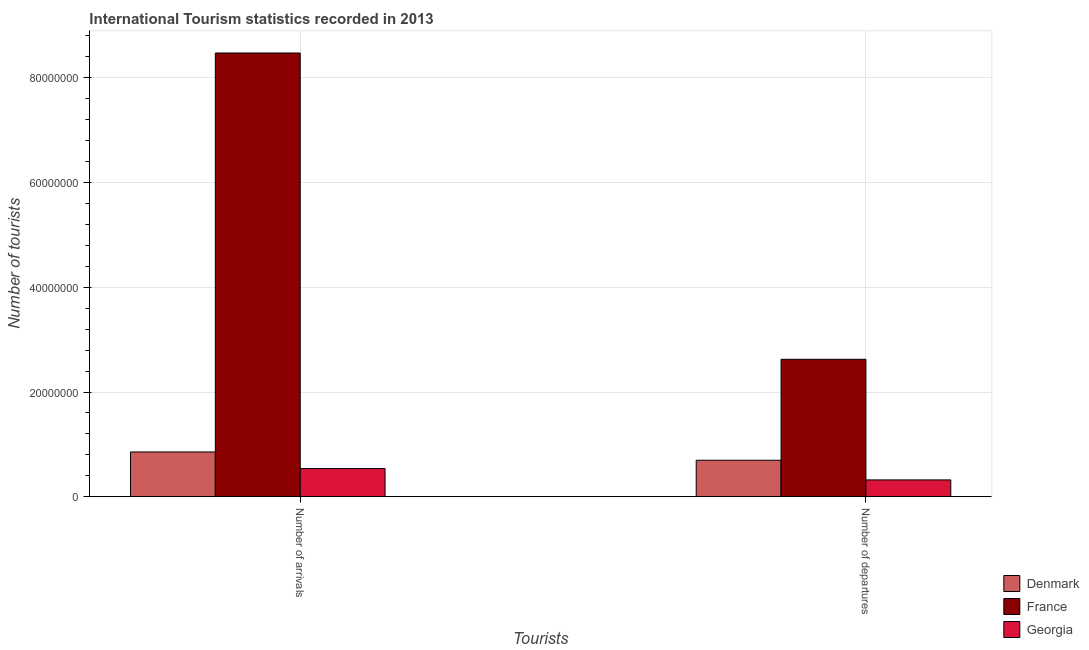How many different coloured bars are there?
Offer a terse response. 3. How many bars are there on the 1st tick from the left?
Provide a short and direct response. 3. What is the label of the 2nd group of bars from the left?
Your response must be concise. Number of departures. What is the number of tourist departures in Denmark?
Your answer should be very brief. 6.98e+06. Across all countries, what is the maximum number of tourist arrivals?
Your response must be concise. 8.47e+07. Across all countries, what is the minimum number of tourist departures?
Your answer should be compact. 3.22e+06. In which country was the number of tourist arrivals minimum?
Ensure brevity in your answer.  Georgia. What is the total number of tourist arrivals in the graph?
Your response must be concise. 9.87e+07. What is the difference between the number of tourist arrivals in France and that in Georgia?
Keep it short and to the point. 7.93e+07. What is the difference between the number of tourist arrivals in Georgia and the number of tourist departures in Denmark?
Keep it short and to the point. -1.58e+06. What is the average number of tourist arrivals per country?
Provide a succinct answer. 3.29e+07. What is the difference between the number of tourist arrivals and number of tourist departures in Denmark?
Give a very brief answer. 1.58e+06. What is the ratio of the number of tourist departures in Georgia to that in Denmark?
Offer a very short reply. 0.46. In how many countries, is the number of tourist arrivals greater than the average number of tourist arrivals taken over all countries?
Your answer should be compact. 1. What does the 1st bar from the left in Number of arrivals represents?
Offer a terse response. Denmark. Are all the bars in the graph horizontal?
Give a very brief answer. No. Are the values on the major ticks of Y-axis written in scientific E-notation?
Your response must be concise. No. Does the graph contain any zero values?
Your answer should be very brief. No. Does the graph contain grids?
Give a very brief answer. Yes. How are the legend labels stacked?
Your answer should be very brief. Vertical. What is the title of the graph?
Offer a terse response. International Tourism statistics recorded in 2013. Does "Argentina" appear as one of the legend labels in the graph?
Offer a very short reply. No. What is the label or title of the X-axis?
Your answer should be very brief. Tourists. What is the label or title of the Y-axis?
Ensure brevity in your answer.  Number of tourists. What is the Number of tourists of Denmark in Number of arrivals?
Give a very brief answer. 8.56e+06. What is the Number of tourists of France in Number of arrivals?
Ensure brevity in your answer.  8.47e+07. What is the Number of tourists in Georgia in Number of arrivals?
Provide a succinct answer. 5.39e+06. What is the Number of tourists in Denmark in Number of departures?
Offer a very short reply. 6.98e+06. What is the Number of tourists in France in Number of departures?
Provide a succinct answer. 2.62e+07. What is the Number of tourists in Georgia in Number of departures?
Offer a very short reply. 3.22e+06. Across all Tourists, what is the maximum Number of tourists of Denmark?
Your answer should be compact. 8.56e+06. Across all Tourists, what is the maximum Number of tourists in France?
Give a very brief answer. 8.47e+07. Across all Tourists, what is the maximum Number of tourists of Georgia?
Make the answer very short. 5.39e+06. Across all Tourists, what is the minimum Number of tourists of Denmark?
Make the answer very short. 6.98e+06. Across all Tourists, what is the minimum Number of tourists of France?
Offer a terse response. 2.62e+07. Across all Tourists, what is the minimum Number of tourists in Georgia?
Keep it short and to the point. 3.22e+06. What is the total Number of tourists in Denmark in the graph?
Offer a very short reply. 1.55e+07. What is the total Number of tourists in France in the graph?
Keep it short and to the point. 1.11e+08. What is the total Number of tourists in Georgia in the graph?
Offer a terse response. 8.61e+06. What is the difference between the Number of tourists in Denmark in Number of arrivals and that in Number of departures?
Your response must be concise. 1.58e+06. What is the difference between the Number of tourists of France in Number of arrivals and that in Number of departures?
Your answer should be very brief. 5.85e+07. What is the difference between the Number of tourists of Georgia in Number of arrivals and that in Number of departures?
Offer a very short reply. 2.17e+06. What is the difference between the Number of tourists in Denmark in Number of arrivals and the Number of tourists in France in Number of departures?
Your response must be concise. -1.77e+07. What is the difference between the Number of tourists in Denmark in Number of arrivals and the Number of tourists in Georgia in Number of departures?
Make the answer very short. 5.34e+06. What is the difference between the Number of tourists of France in Number of arrivals and the Number of tourists of Georgia in Number of departures?
Offer a very short reply. 8.15e+07. What is the average Number of tourists of Denmark per Tourists?
Your response must be concise. 7.77e+06. What is the average Number of tourists in France per Tourists?
Provide a succinct answer. 5.55e+07. What is the average Number of tourists of Georgia per Tourists?
Provide a short and direct response. 4.31e+06. What is the difference between the Number of tourists of Denmark and Number of tourists of France in Number of arrivals?
Offer a terse response. -7.62e+07. What is the difference between the Number of tourists in Denmark and Number of tourists in Georgia in Number of arrivals?
Offer a very short reply. 3.16e+06. What is the difference between the Number of tourists in France and Number of tourists in Georgia in Number of arrivals?
Your answer should be very brief. 7.93e+07. What is the difference between the Number of tourists of Denmark and Number of tourists of France in Number of departures?
Give a very brief answer. -1.93e+07. What is the difference between the Number of tourists in Denmark and Number of tourists in Georgia in Number of departures?
Your answer should be very brief. 3.76e+06. What is the difference between the Number of tourists of France and Number of tourists of Georgia in Number of departures?
Ensure brevity in your answer.  2.30e+07. What is the ratio of the Number of tourists in Denmark in Number of arrivals to that in Number of departures?
Your answer should be very brief. 1.23. What is the ratio of the Number of tourists of France in Number of arrivals to that in Number of departures?
Keep it short and to the point. 3.23. What is the ratio of the Number of tourists of Georgia in Number of arrivals to that in Number of departures?
Your answer should be compact. 1.67. What is the difference between the highest and the second highest Number of tourists of Denmark?
Make the answer very short. 1.58e+06. What is the difference between the highest and the second highest Number of tourists in France?
Your answer should be very brief. 5.85e+07. What is the difference between the highest and the second highest Number of tourists of Georgia?
Offer a very short reply. 2.17e+06. What is the difference between the highest and the lowest Number of tourists of Denmark?
Offer a very short reply. 1.58e+06. What is the difference between the highest and the lowest Number of tourists of France?
Provide a short and direct response. 5.85e+07. What is the difference between the highest and the lowest Number of tourists of Georgia?
Your response must be concise. 2.17e+06. 